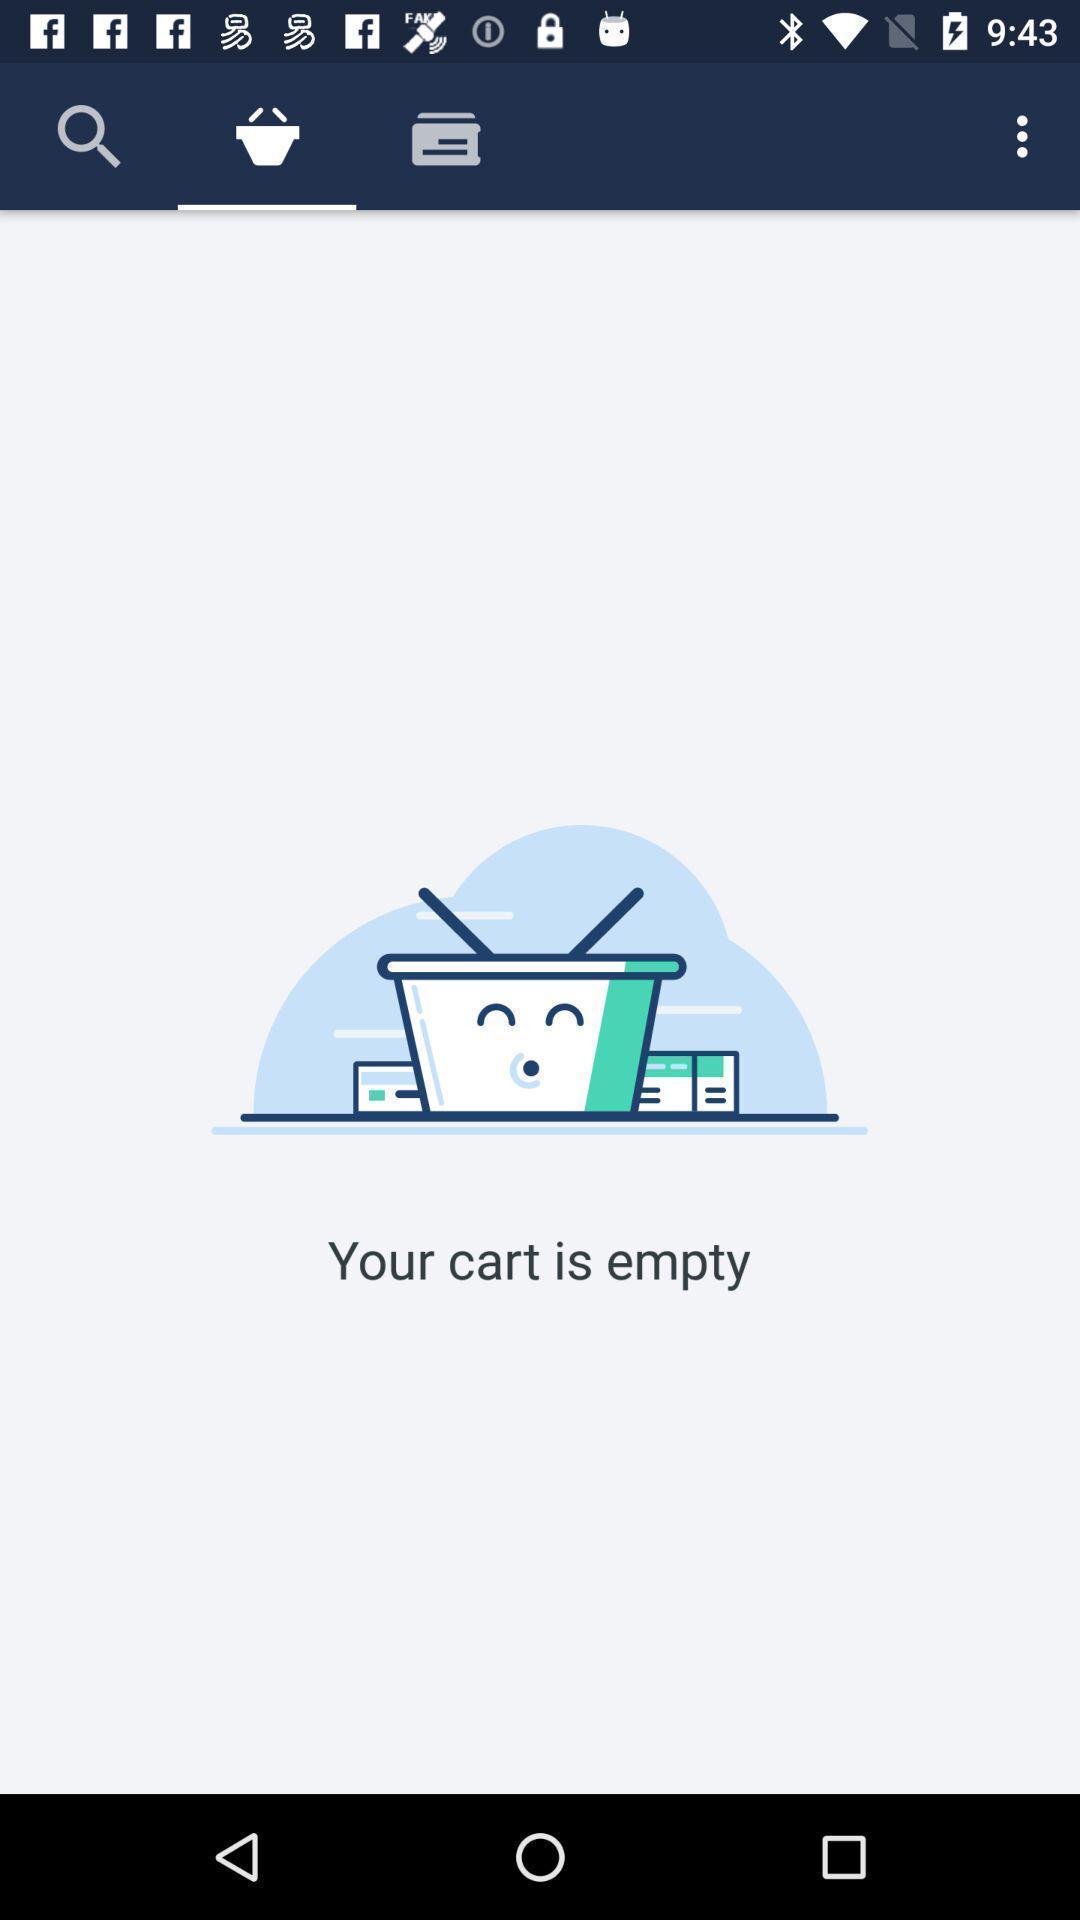Summarize the main components in this picture. Social app for shopping purpose. 